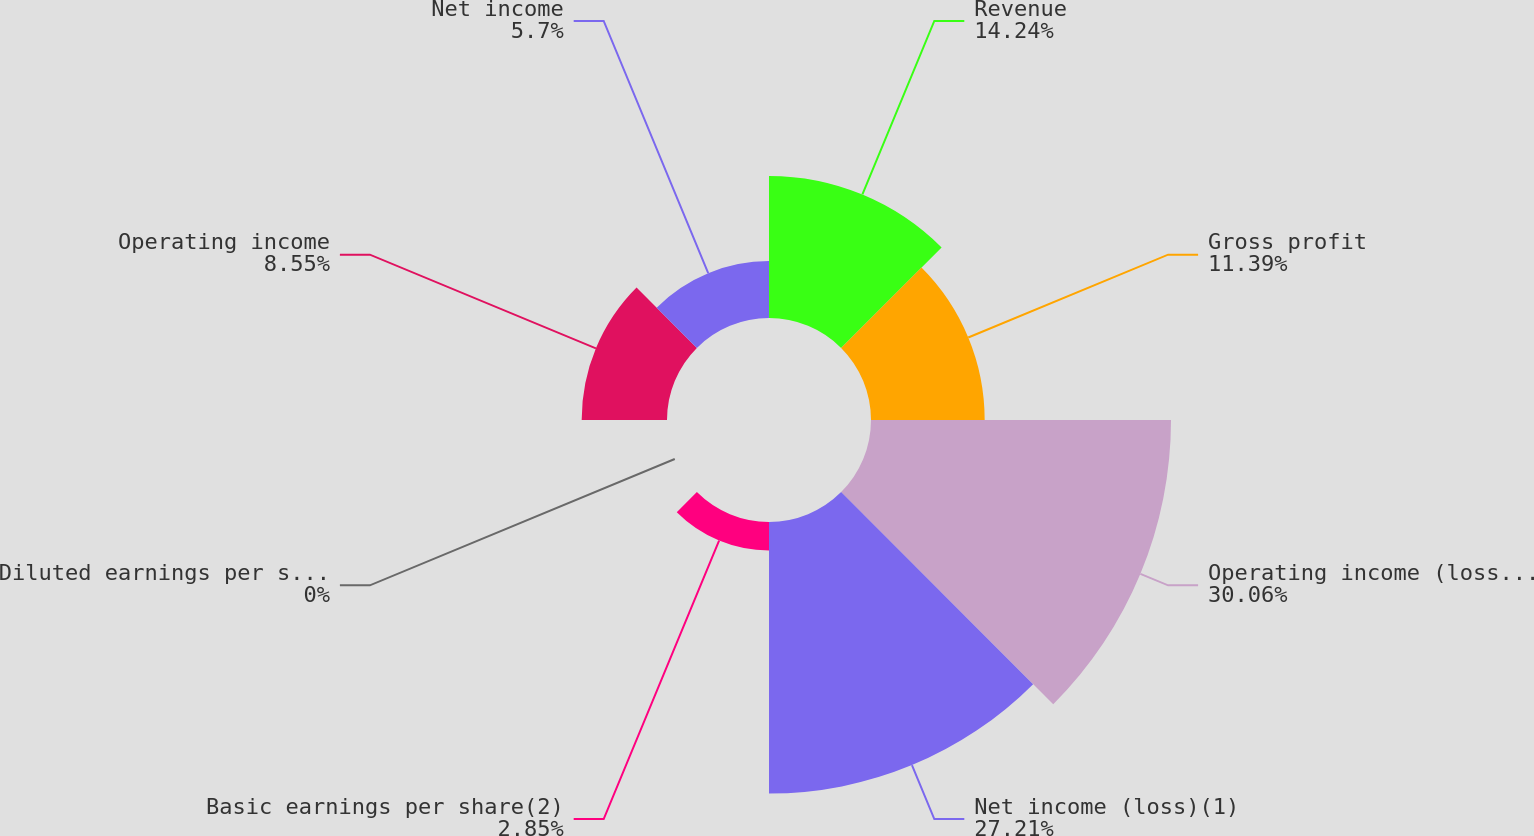<chart> <loc_0><loc_0><loc_500><loc_500><pie_chart><fcel>Revenue<fcel>Gross profit<fcel>Operating income (loss)(1)<fcel>Net income (loss)(1)<fcel>Basic earnings per share(2)<fcel>Diluted earnings per share(2)<fcel>Operating income<fcel>Net income<nl><fcel>14.24%<fcel>11.39%<fcel>30.06%<fcel>27.21%<fcel>2.85%<fcel>0.0%<fcel>8.55%<fcel>5.7%<nl></chart> 